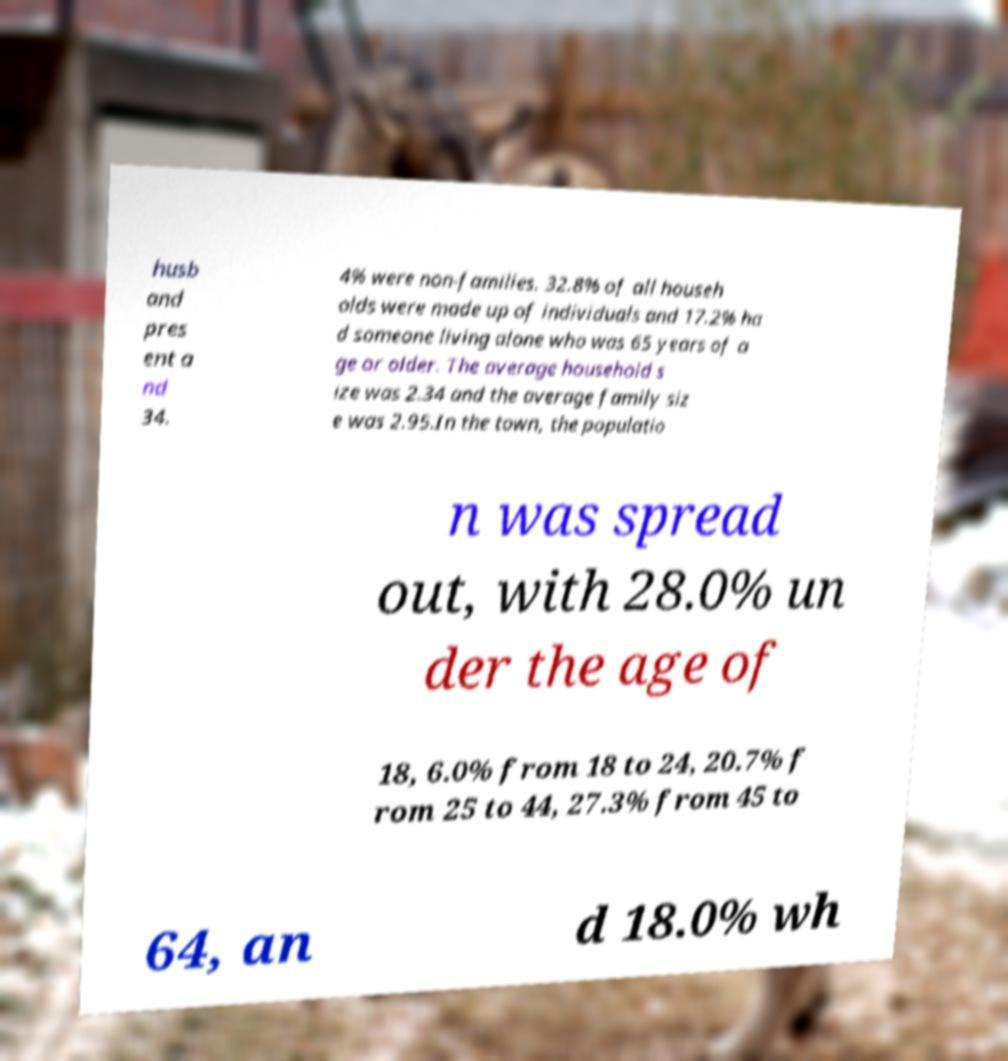There's text embedded in this image that I need extracted. Can you transcribe it verbatim? husb and pres ent a nd 34. 4% were non-families. 32.8% of all househ olds were made up of individuals and 17.2% ha d someone living alone who was 65 years of a ge or older. The average household s ize was 2.34 and the average family siz e was 2.95.In the town, the populatio n was spread out, with 28.0% un der the age of 18, 6.0% from 18 to 24, 20.7% f rom 25 to 44, 27.3% from 45 to 64, an d 18.0% wh 